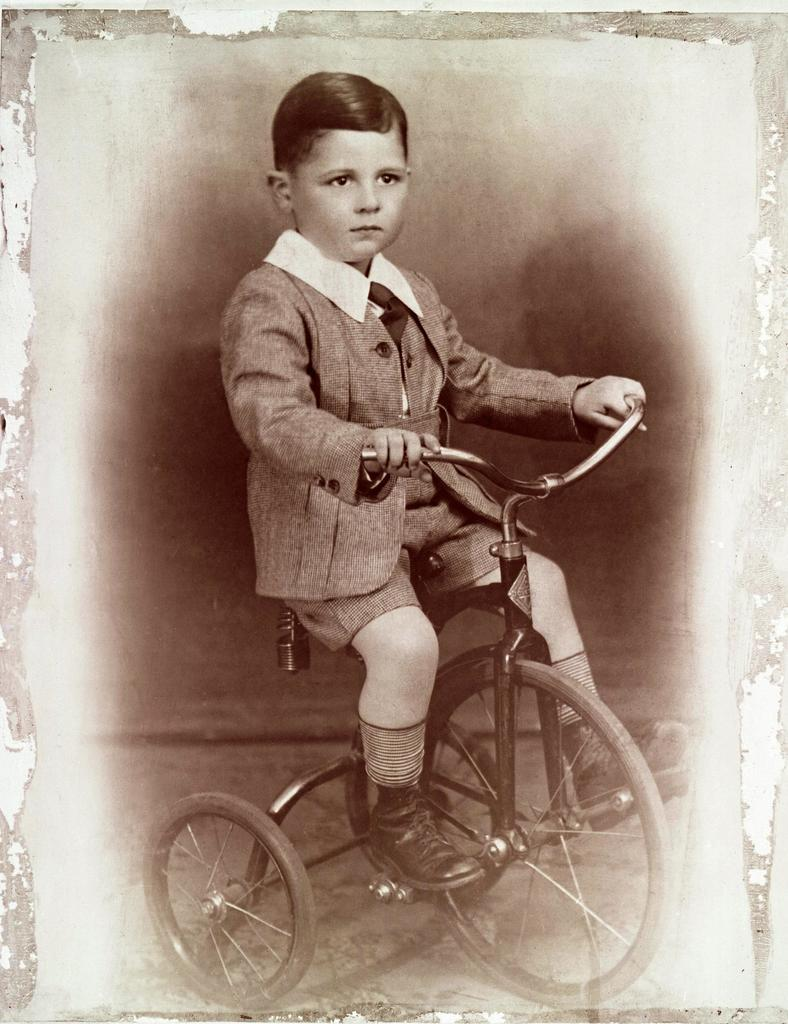Who is present in the image? There is a man in the image. What is the man doing in the image? The man is sitting on a bicycle. What is the color scheme of the image? The image is in black and white color. What type of hammer is the man using in the image? There is no hammer present in the image; the man is sitting on a bicycle. What nation is the man representing in the image? The image does not provide any information about the man representing a specific nation. 